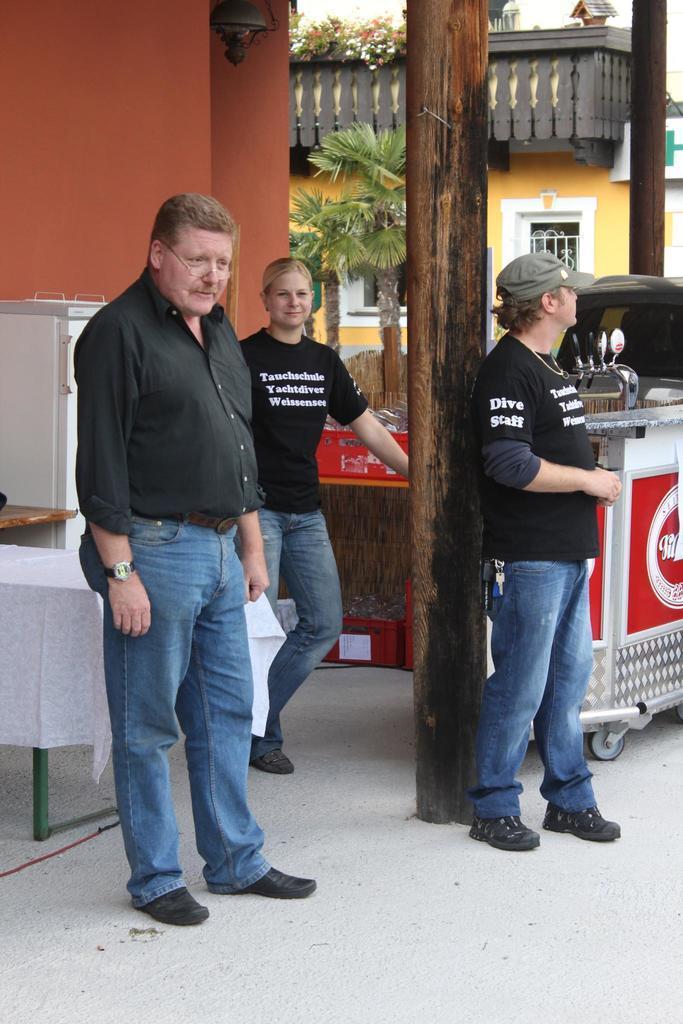Describe this image in one or two sentences. On the background we can see building with windows and this is a tree near to the building. Here we can see three persons standing. He wore spectacles. This man wore a cap. We can see a table with white cloth behind to this man. 